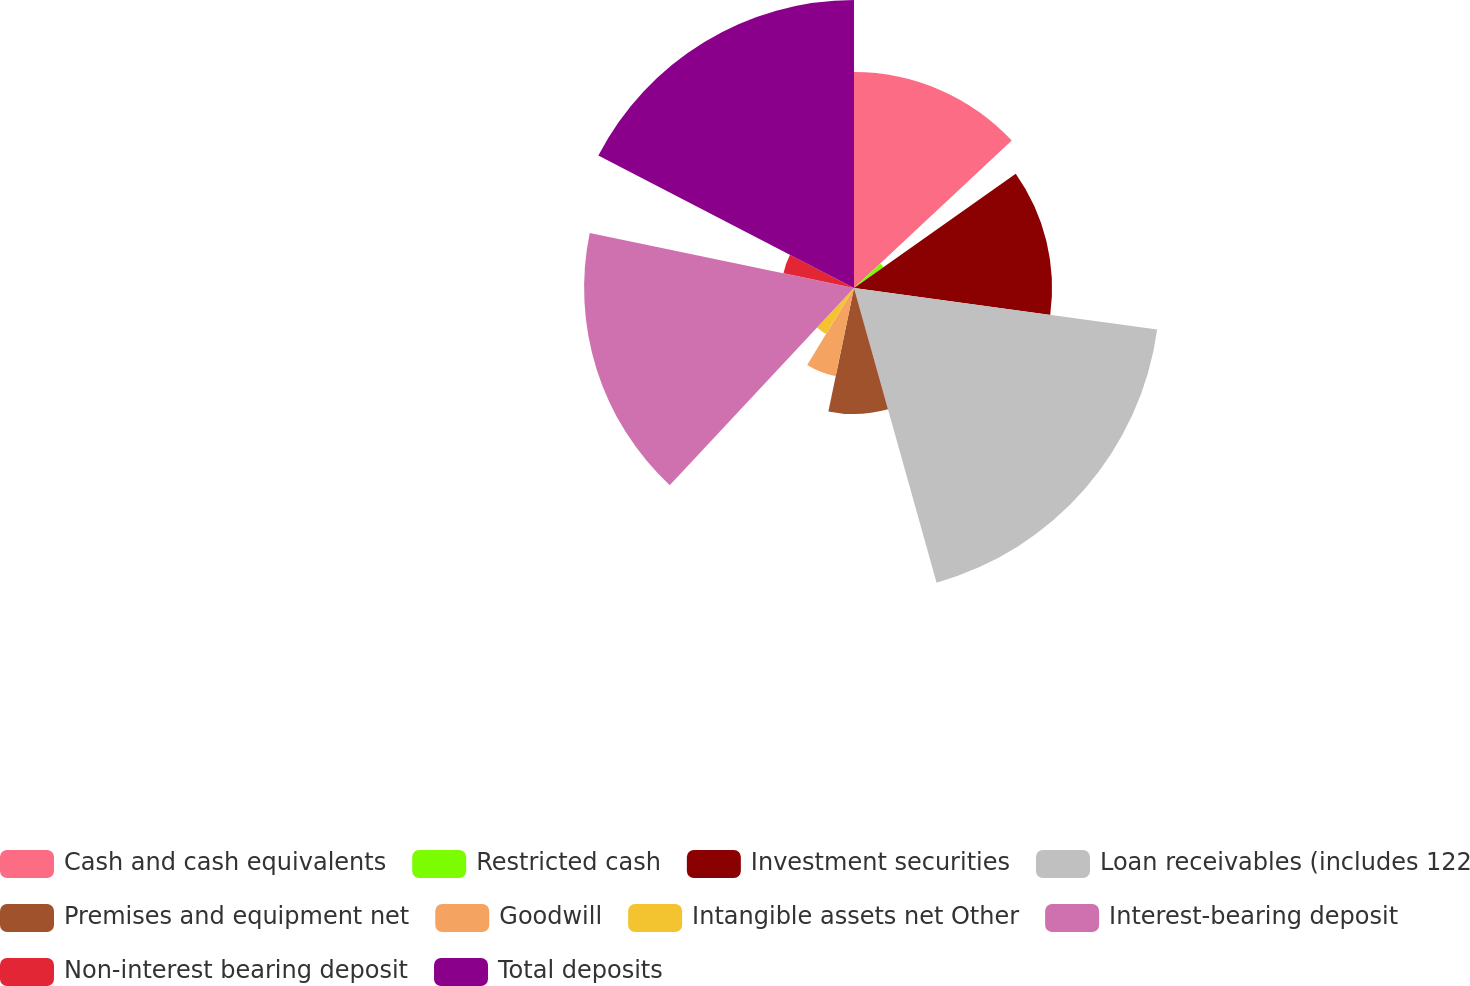Convert chart. <chart><loc_0><loc_0><loc_500><loc_500><pie_chart><fcel>Cash and cash equivalents<fcel>Restricted cash<fcel>Investment securities<fcel>Loan receivables (includes 122<fcel>Premises and equipment net<fcel>Goodwill<fcel>Intangible assets net Other<fcel>Interest-bearing deposit<fcel>Non-interest bearing deposit<fcel>Total deposits<nl><fcel>13.04%<fcel>2.17%<fcel>11.96%<fcel>18.48%<fcel>7.61%<fcel>5.44%<fcel>3.26%<fcel>16.3%<fcel>4.35%<fcel>17.39%<nl></chart> 